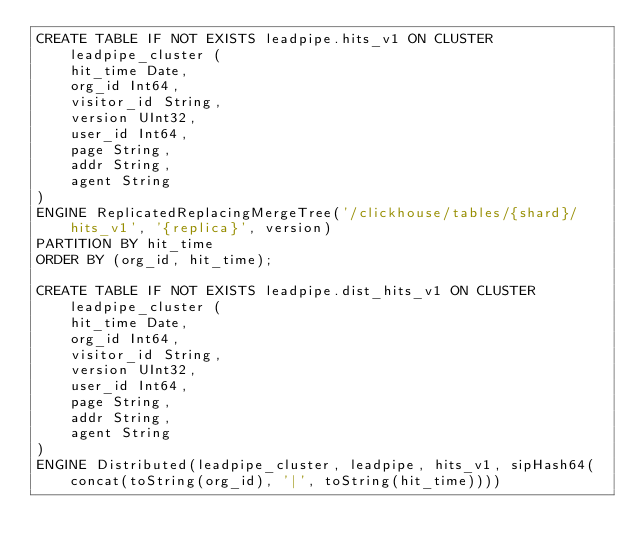<code> <loc_0><loc_0><loc_500><loc_500><_SQL_>CREATE TABLE IF NOT EXISTS leadpipe.hits_v1 ON CLUSTER leadpipe_cluster (
    hit_time Date,
    org_id Int64,
    visitor_id String,
    version UInt32,
    user_id Int64,
    page String,
    addr String,
    agent String
)
ENGINE ReplicatedReplacingMergeTree('/clickhouse/tables/{shard}/hits_v1', '{replica}', version)
PARTITION BY hit_time
ORDER BY (org_id, hit_time);

CREATE TABLE IF NOT EXISTS leadpipe.dist_hits_v1 ON CLUSTER leadpipe_cluster (
    hit_time Date,
    org_id Int64,
    visitor_id String,
    version UInt32,
    user_id Int64,
    page String,
    addr String,
    agent String
)
ENGINE Distributed(leadpipe_cluster, leadpipe, hits_v1, sipHash64(concat(toString(org_id), '|', toString(hit_time))))</code> 